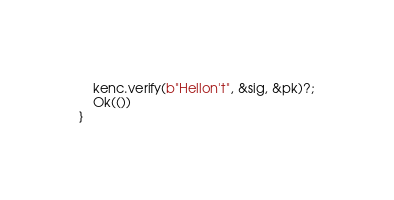<code> <loc_0><loc_0><loc_500><loc_500><_Rust_>    kenc.verify(b"Hellon't", &sig, &pk)?;
    Ok(())
}
</code> 